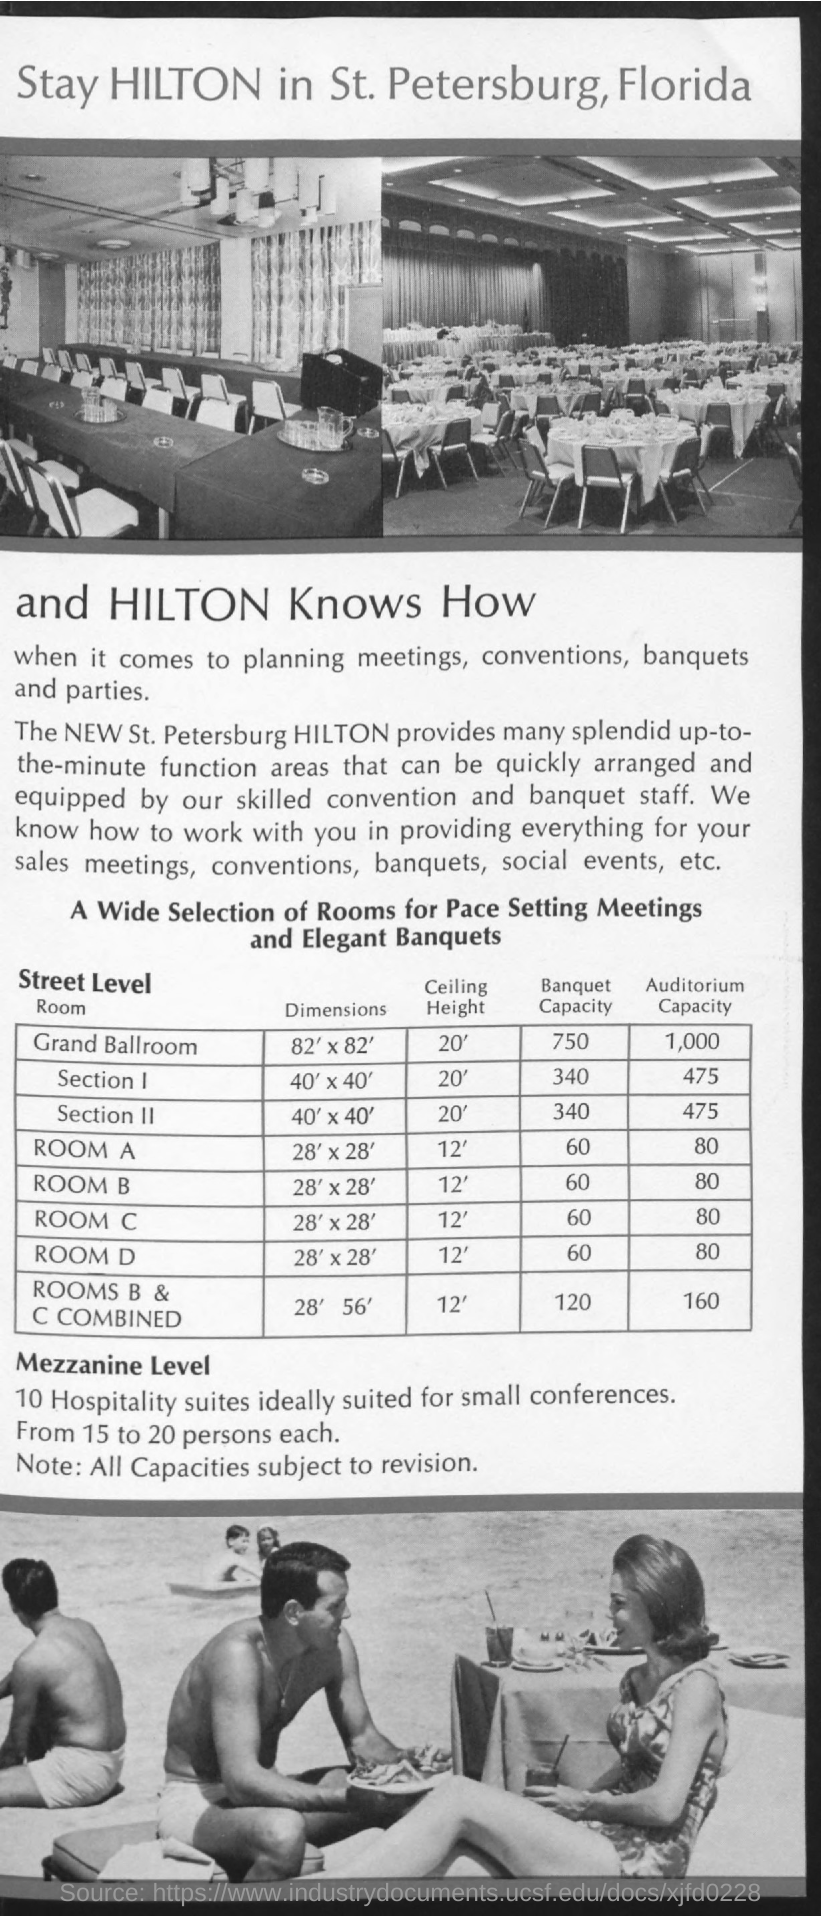what is the auditorium capacity of Room A?
 80 